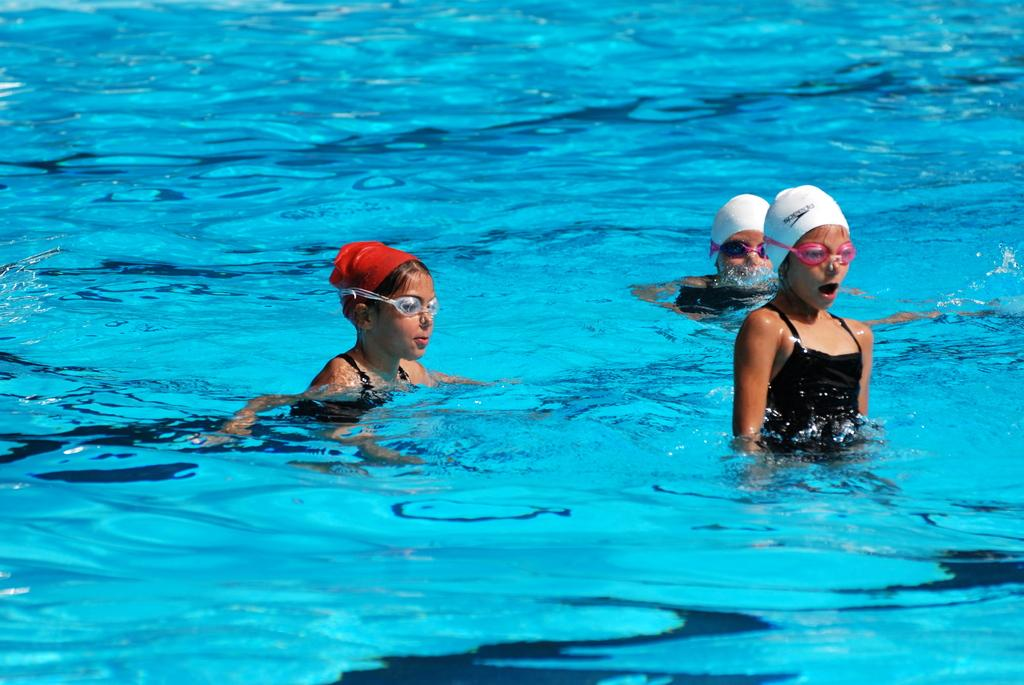How many people are in the image? There are three persons in the image. What are the persons doing in the image? The persons are swimming. What are the persons wearing while swimming? The persons are wearing caps. What is at the bottom of the image? There is water at the bottom of the image. How much money can be seen in the image? There is no money visible in the image; it features three persons swimming while wearing caps. What type of shop can be seen in the background of the image? There is no shop present in the image; it only shows three persons swimming in water. 